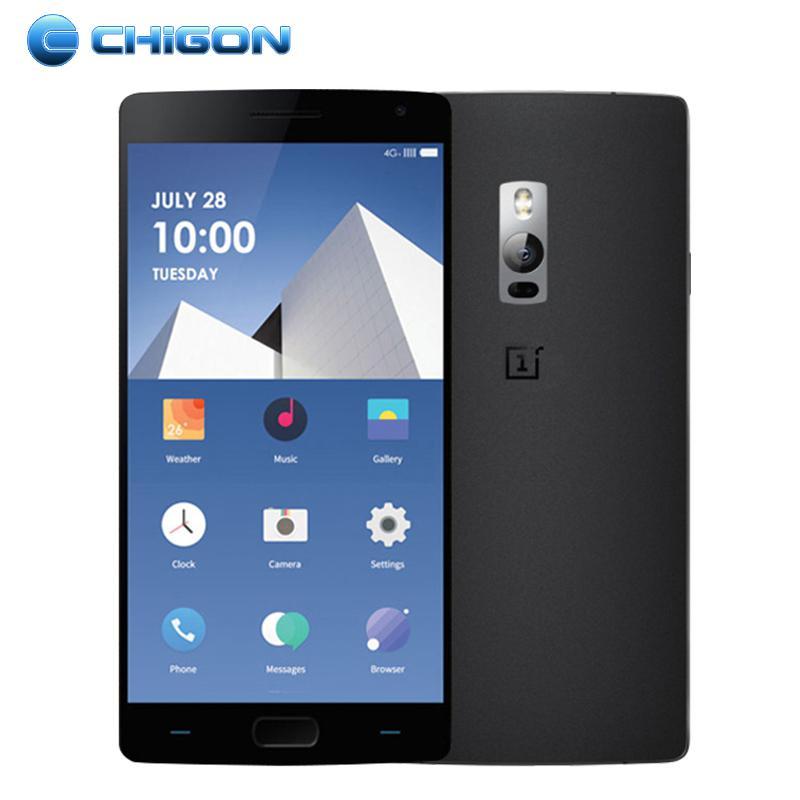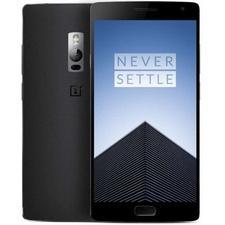The first image is the image on the left, the second image is the image on the right. Analyze the images presented: Is the assertion "The phone screen is completely visible in each image." valid? Answer yes or no. Yes. The first image is the image on the left, the second image is the image on the right. Considering the images on both sides, is "Each image shows a device viewed head-on, and at least one of the images shows an overlapping device." valid? Answer yes or no. Yes. 